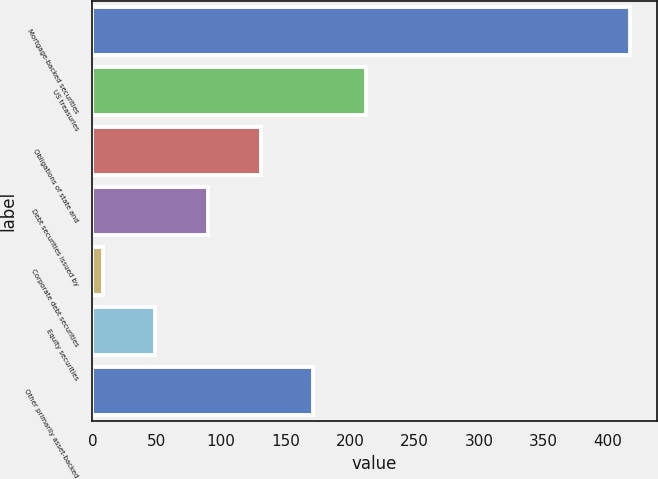Convert chart to OTSL. <chart><loc_0><loc_0><loc_500><loc_500><bar_chart><fcel>Mortgage-backed securities<fcel>US treasuries<fcel>Obligations of state and<fcel>Debt securities issued by<fcel>Corporate debt securities<fcel>Equity securities<fcel>Other primarily asset-backed<nl><fcel>417<fcel>212.5<fcel>130.7<fcel>89.8<fcel>8<fcel>48.9<fcel>171.6<nl></chart> 